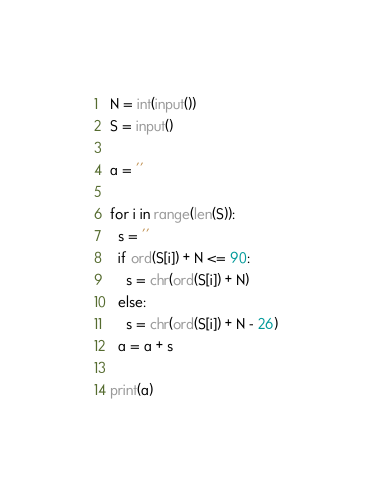Convert code to text. <code><loc_0><loc_0><loc_500><loc_500><_Python_>N = int(input())
S = input()

a = ''

for i in range(len(S)):
  s = ''
  if ord(S[i]) + N <= 90:
    s = chr(ord(S[i]) + N)
  else:
    s = chr(ord(S[i]) + N - 26)
  a = a + s
  
print(a)</code> 